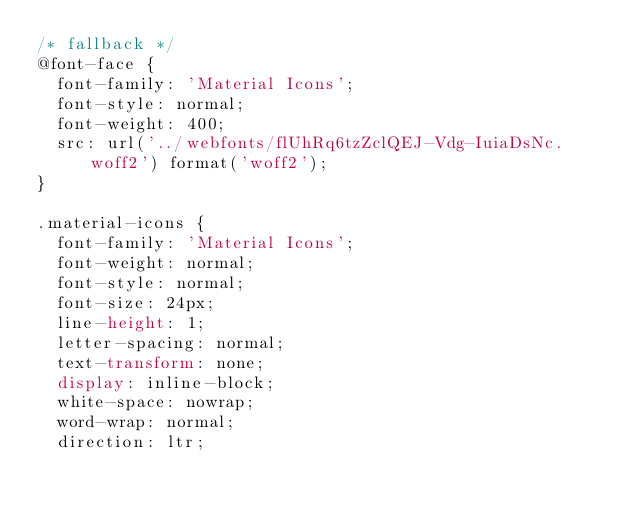<code> <loc_0><loc_0><loc_500><loc_500><_CSS_>/* fallback */
@font-face {
  font-family: 'Material Icons';
  font-style: normal;
  font-weight: 400;
  src: url('../webfonts/flUhRq6tzZclQEJ-Vdg-IuiaDsNc.woff2') format('woff2');
}

.material-icons {
  font-family: 'Material Icons';
  font-weight: normal;
  font-style: normal;
  font-size: 24px;
  line-height: 1;
  letter-spacing: normal;
  text-transform: none;
  display: inline-block;
  white-space: nowrap;
  word-wrap: normal;
  direction: ltr;</code> 